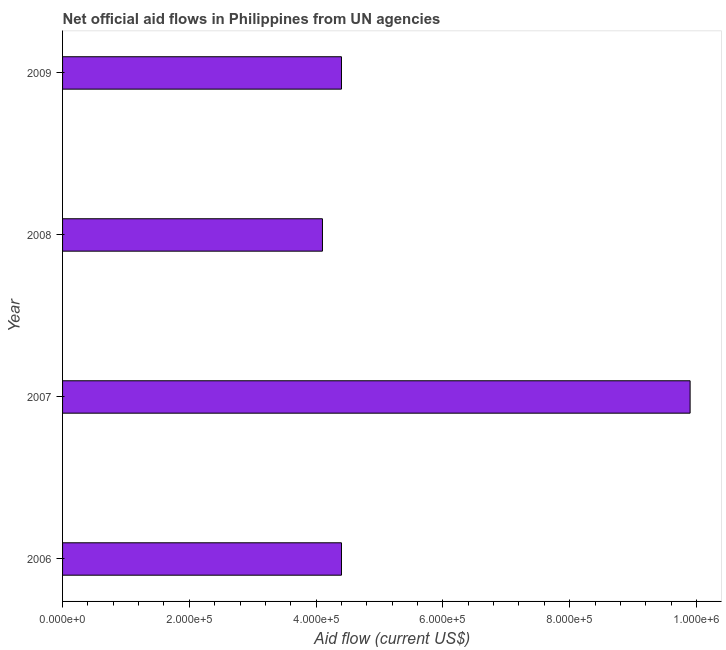Does the graph contain grids?
Your answer should be very brief. No. What is the title of the graph?
Provide a short and direct response. Net official aid flows in Philippines from UN agencies. What is the net official flows from un agencies in 2007?
Make the answer very short. 9.90e+05. Across all years, what is the maximum net official flows from un agencies?
Your answer should be very brief. 9.90e+05. What is the sum of the net official flows from un agencies?
Give a very brief answer. 2.28e+06. What is the difference between the net official flows from un agencies in 2006 and 2007?
Your answer should be very brief. -5.50e+05. What is the average net official flows from un agencies per year?
Make the answer very short. 5.70e+05. In how many years, is the net official flows from un agencies greater than 920000 US$?
Keep it short and to the point. 1. Do a majority of the years between 2008 and 2007 (inclusive) have net official flows from un agencies greater than 160000 US$?
Provide a succinct answer. No. What is the ratio of the net official flows from un agencies in 2006 to that in 2008?
Keep it short and to the point. 1.07. Is the difference between the net official flows from un agencies in 2006 and 2009 greater than the difference between any two years?
Your answer should be very brief. No. Is the sum of the net official flows from un agencies in 2008 and 2009 greater than the maximum net official flows from un agencies across all years?
Make the answer very short. No. What is the difference between the highest and the lowest net official flows from un agencies?
Your response must be concise. 5.80e+05. How many years are there in the graph?
Your response must be concise. 4. What is the difference between two consecutive major ticks on the X-axis?
Your response must be concise. 2.00e+05. What is the Aid flow (current US$) in 2006?
Your answer should be very brief. 4.40e+05. What is the Aid flow (current US$) of 2007?
Offer a very short reply. 9.90e+05. What is the Aid flow (current US$) of 2008?
Make the answer very short. 4.10e+05. What is the Aid flow (current US$) of 2009?
Give a very brief answer. 4.40e+05. What is the difference between the Aid flow (current US$) in 2006 and 2007?
Give a very brief answer. -5.50e+05. What is the difference between the Aid flow (current US$) in 2006 and 2009?
Give a very brief answer. 0. What is the difference between the Aid flow (current US$) in 2007 and 2008?
Provide a succinct answer. 5.80e+05. What is the ratio of the Aid flow (current US$) in 2006 to that in 2007?
Give a very brief answer. 0.44. What is the ratio of the Aid flow (current US$) in 2006 to that in 2008?
Your answer should be very brief. 1.07. What is the ratio of the Aid flow (current US$) in 2006 to that in 2009?
Your response must be concise. 1. What is the ratio of the Aid flow (current US$) in 2007 to that in 2008?
Your answer should be very brief. 2.42. What is the ratio of the Aid flow (current US$) in 2007 to that in 2009?
Offer a very short reply. 2.25. What is the ratio of the Aid flow (current US$) in 2008 to that in 2009?
Ensure brevity in your answer.  0.93. 